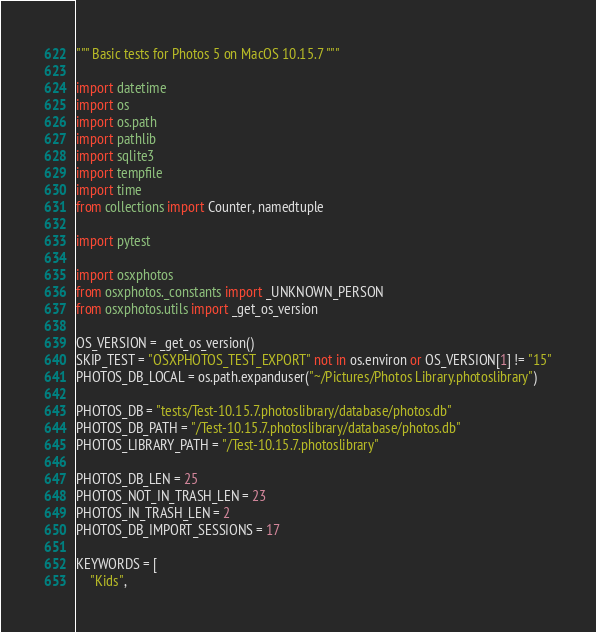Convert code to text. <code><loc_0><loc_0><loc_500><loc_500><_Python_>""" Basic tests for Photos 5 on MacOS 10.15.7 """

import datetime
import os
import os.path
import pathlib
import sqlite3
import tempfile
import time
from collections import Counter, namedtuple

import pytest

import osxphotos
from osxphotos._constants import _UNKNOWN_PERSON
from osxphotos.utils import _get_os_version

OS_VERSION = _get_os_version()
SKIP_TEST = "OSXPHOTOS_TEST_EXPORT" not in os.environ or OS_VERSION[1] != "15"
PHOTOS_DB_LOCAL = os.path.expanduser("~/Pictures/Photos Library.photoslibrary")

PHOTOS_DB = "tests/Test-10.15.7.photoslibrary/database/photos.db"
PHOTOS_DB_PATH = "/Test-10.15.7.photoslibrary/database/photos.db"
PHOTOS_LIBRARY_PATH = "/Test-10.15.7.photoslibrary"

PHOTOS_DB_LEN = 25
PHOTOS_NOT_IN_TRASH_LEN = 23
PHOTOS_IN_TRASH_LEN = 2
PHOTOS_DB_IMPORT_SESSIONS = 17

KEYWORDS = [
    "Kids",</code> 